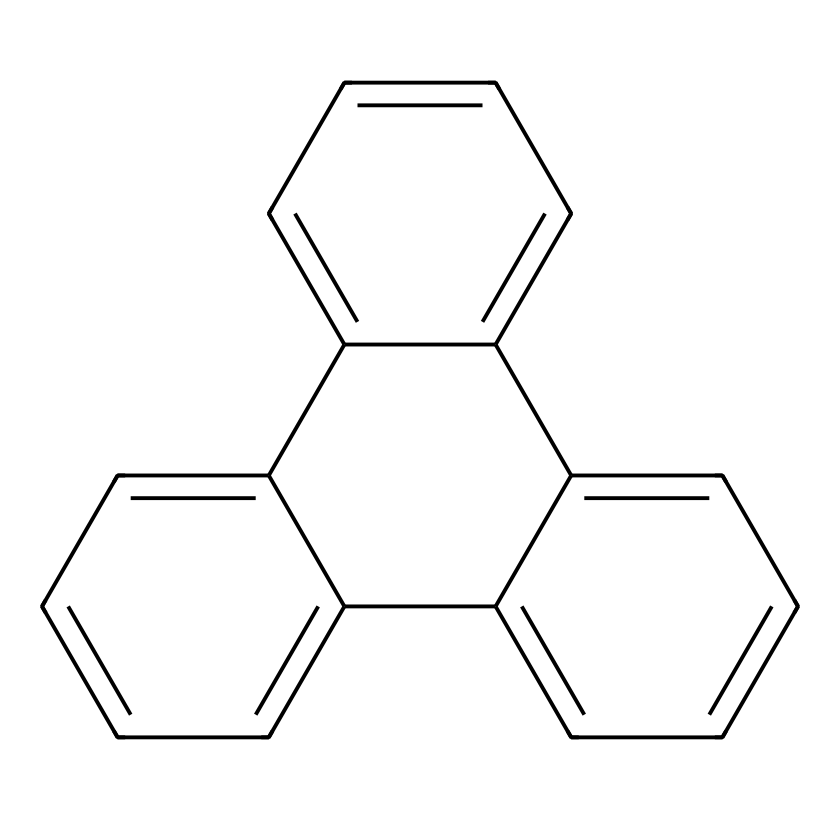How many carbon atoms are in this PAH? The SMILES representation indicates a structure consisting of interconnected aromatic rings. Counting the carbons represented in the ring structure shows there are 18 carbon atoms in total.
Answer: 18 How many hydrogen atoms are attached to this structure? For polycyclic aromatic hydrocarbons, each carbon typically has one hydrogen unless it is bonded to another carbon or is part of a double bond. Based on the structure, we can count and deduce there are 12 hydrogen atoms associated with the 18 carbon atoms in its specific arrangement.
Answer: 12 What is the molecular formula of this compound? To derive the molecular formula, we combine the numbers of carbon and hydrogen atoms counted from the structure. Thus, with 18 carbon atoms and 12 hydrogen atoms, the molecular formula is C18H12.
Answer: C18H12 What type of compound is this?: This structure is a type of hydrocarbon known as a polycyclic aromatic hydrocarbon, characterized by multiple fused benzene rings.
Answer: polycyclic aromatic hydrocarbon How does the structure affect its solubility in organic solvents? The extensive aromatic character and the presence of interconnected rings (fused structure) typically increase hydrophobic interactions, promoting solubility in non-polar organic solvents while decreasing solubility in water.
Answer: increases solubility in organic solvents What role could PAHs play in Martian meteorites? PAHs in Martian meteorites may indicate past biological processes or chemical reactions on Mars, suggesting potential organic chemistry relevant to astrobiology.
Answer: indicate past biological processes 